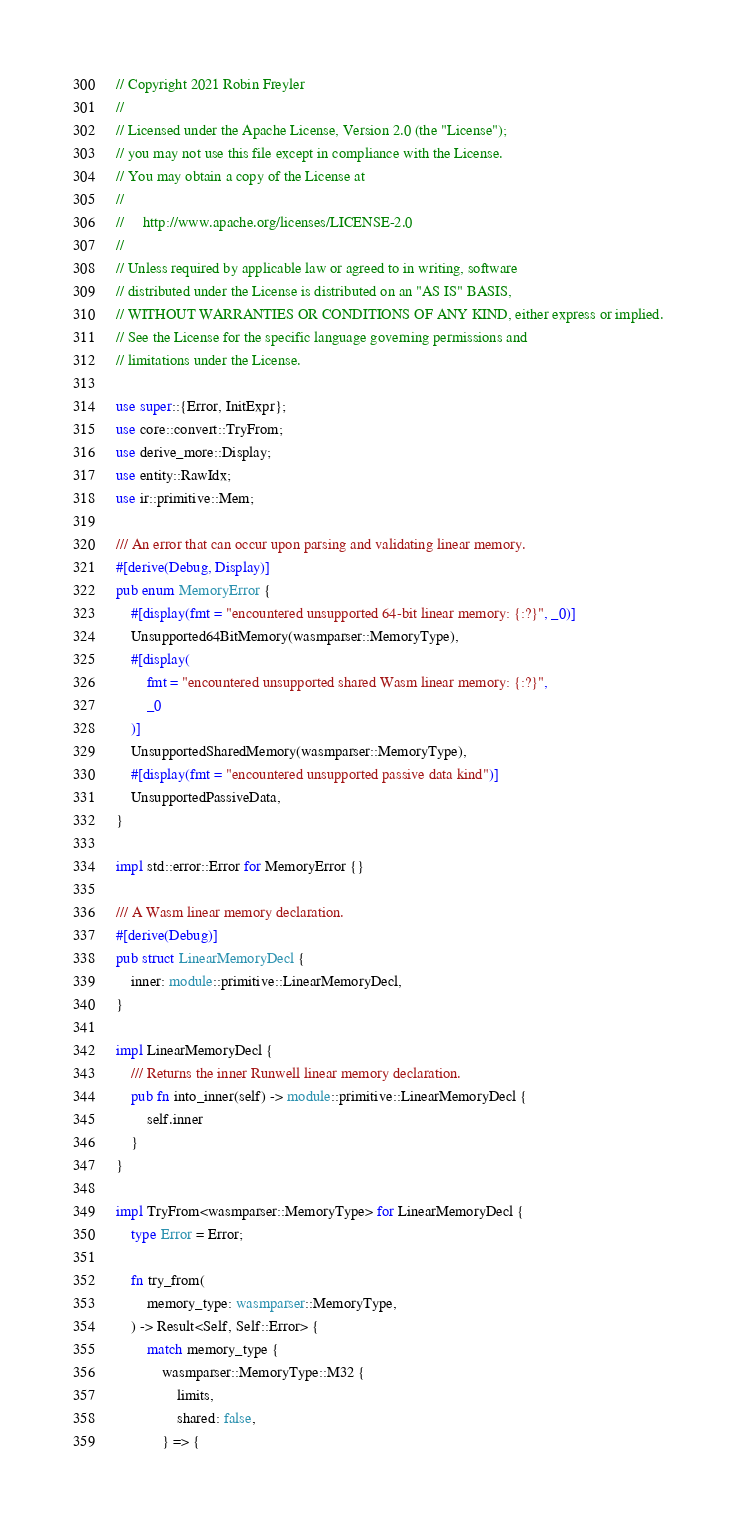Convert code to text. <code><loc_0><loc_0><loc_500><loc_500><_Rust_>// Copyright 2021 Robin Freyler
//
// Licensed under the Apache License, Version 2.0 (the "License");
// you may not use this file except in compliance with the License.
// You may obtain a copy of the License at
//
//     http://www.apache.org/licenses/LICENSE-2.0
//
// Unless required by applicable law or agreed to in writing, software
// distributed under the License is distributed on an "AS IS" BASIS,
// WITHOUT WARRANTIES OR CONDITIONS OF ANY KIND, either express or implied.
// See the License for the specific language governing permissions and
// limitations under the License.

use super::{Error, InitExpr};
use core::convert::TryFrom;
use derive_more::Display;
use entity::RawIdx;
use ir::primitive::Mem;

/// An error that can occur upon parsing and validating linear memory.
#[derive(Debug, Display)]
pub enum MemoryError {
    #[display(fmt = "encountered unsupported 64-bit linear memory: {:?}", _0)]
    Unsupported64BitMemory(wasmparser::MemoryType),
    #[display(
        fmt = "encountered unsupported shared Wasm linear memory: {:?}",
        _0
    )]
    UnsupportedSharedMemory(wasmparser::MemoryType),
    #[display(fmt = "encountered unsupported passive data kind")]
    UnsupportedPassiveData,
}

impl std::error::Error for MemoryError {}

/// A Wasm linear memory declaration.
#[derive(Debug)]
pub struct LinearMemoryDecl {
    inner: module::primitive::LinearMemoryDecl,
}

impl LinearMemoryDecl {
    /// Returns the inner Runwell linear memory declaration.
    pub fn into_inner(self) -> module::primitive::LinearMemoryDecl {
        self.inner
    }
}

impl TryFrom<wasmparser::MemoryType> for LinearMemoryDecl {
    type Error = Error;

    fn try_from(
        memory_type: wasmparser::MemoryType,
    ) -> Result<Self, Self::Error> {
        match memory_type {
            wasmparser::MemoryType::M32 {
                limits,
                shared: false,
            } => {</code> 